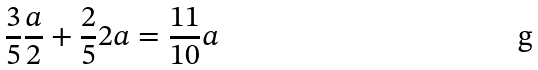Convert formula to latex. <formula><loc_0><loc_0><loc_500><loc_500>\frac { 3 } { 5 } \frac { a } { 2 } + \frac { 2 } { 5 } 2 a = \frac { 1 1 } { 1 0 } a</formula> 